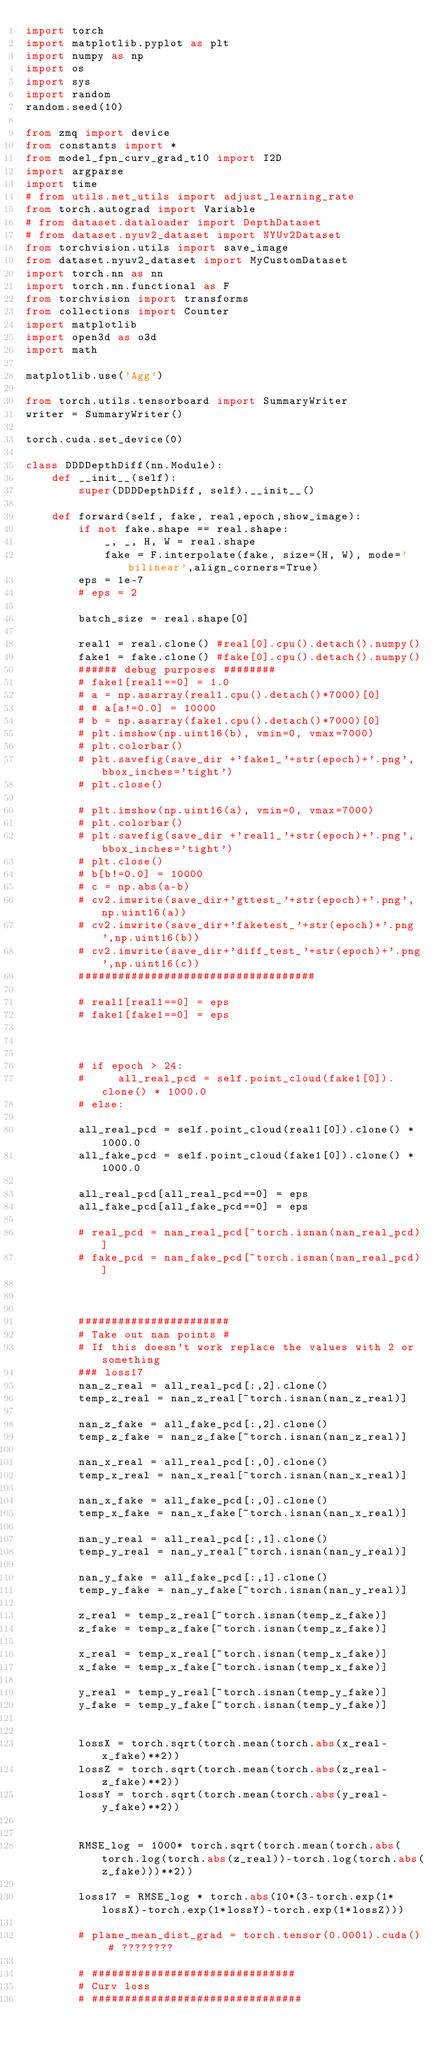<code> <loc_0><loc_0><loc_500><loc_500><_Python_>import torch
import matplotlib.pyplot as plt
import numpy as np
import os
import sys
import random
random.seed(10)

from zmq import device
from constants import *
from model_fpn_curv_grad_t10 import I2D
import argparse
import time
# from utils.net_utils import adjust_learning_rate
from torch.autograd import Variable
# from dataset.dataloader import DepthDataset
# from dataset.nyuv2_dataset import NYUv2Dataset
from torchvision.utils import save_image
from dataset.nyuv2_dataset import MyCustomDataset
import torch.nn as nn
import torch.nn.functional as F
from torchvision import transforms
from collections import Counter
import matplotlib
import open3d as o3d
import math

matplotlib.use('Agg')

from torch.utils.tensorboard import SummaryWriter
writer = SummaryWriter()

torch.cuda.set_device(0)

class DDDDepthDiff(nn.Module):
    def __init__(self):
        super(DDDDepthDiff, self).__init__()

    def forward(self, fake, real,epoch,show_image):
        if not fake.shape == real.shape:
            _, _, H, W = real.shape
            fake = F.interpolate(fake, size=(H, W), mode='bilinear',align_corners=True)
        eps = 1e-7
        # eps = 2

        batch_size = real.shape[0]
        
        real1 = real.clone() #real[0].cpu().detach().numpy()
        fake1 = fake.clone() #fake[0].cpu().detach().numpy()
        ###### debug purposes ########
        # fake1[real1==0] = 1.0
        # a = np.asarray(real1.cpu().detach()*7000)[0]
        # # a[a!=0.0] = 10000
        # b = np.asarray(fake1.cpu().detach()*7000)[0]
        # plt.imshow(np.uint16(b), vmin=0, vmax=7000)
        # plt.colorbar()
        # plt.savefig(save_dir +'fake1_'+str(epoch)+'.png',bbox_inches='tight')
        # plt.close()

        # plt.imshow(np.uint16(a), vmin=0, vmax=7000)
        # plt.colorbar()
        # plt.savefig(save_dir +'real1_'+str(epoch)+'.png',bbox_inches='tight')
        # plt.close()
        # b[b!=0.0] = 10000
        # c = np.abs(a-b)
        # cv2.imwrite(save_dir+'gttest_'+str(epoch)+'.png',np.uint16(a))
        # cv2.imwrite(save_dir+'faketest_'+str(epoch)+'.png',np.uint16(b))
        # cv2.imwrite(save_dir+'diff_test_'+str(epoch)+'.png',np.uint16(c))
        ####################################

        # real1[real1==0] = eps
        # fake1[fake1==0] = eps



        # if epoch > 24:
        #     all_real_pcd = self.point_cloud(fake1[0]).clone() * 1000.0
        # else:    

        all_real_pcd = self.point_cloud(real1[0]).clone() * 1000.0
        all_fake_pcd = self.point_cloud(fake1[0]).clone() * 1000.0

        all_real_pcd[all_real_pcd==0] = eps
        all_fake_pcd[all_fake_pcd==0] = eps

        # real_pcd = nan_real_pcd[~torch.isnan(nan_real_pcd)]
        # fake_pcd = nan_fake_pcd[~torch.isnan(nan_real_pcd)]

        
      
        #######################
        # Take out nan points #
        # If this doesn't work replace the values with 2 or something
        ### loss17
        nan_z_real = all_real_pcd[:,2].clone()
        temp_z_real = nan_z_real[~torch.isnan(nan_z_real)]
       
        nan_z_fake = all_fake_pcd[:,2].clone()
        temp_z_fake = nan_z_fake[~torch.isnan(nan_z_real)]
        
        nan_x_real = all_real_pcd[:,0].clone()
        temp_x_real = nan_x_real[~torch.isnan(nan_x_real)]
        
        nan_x_fake = all_fake_pcd[:,0].clone()
        temp_x_fake = nan_x_fake[~torch.isnan(nan_x_real)]
        
        nan_y_real = all_real_pcd[:,1].clone()
        temp_y_real = nan_y_real[~torch.isnan(nan_y_real)]
        
        nan_y_fake = all_fake_pcd[:,1].clone()
        temp_y_fake = nan_y_fake[~torch.isnan(nan_y_real)]

        z_real = temp_z_real[~torch.isnan(temp_z_fake)]
        z_fake = temp_z_fake[~torch.isnan(temp_z_fake)]

        x_real = temp_x_real[~torch.isnan(temp_x_fake)]
        x_fake = temp_x_fake[~torch.isnan(temp_x_fake)]

        y_real = temp_y_real[~torch.isnan(temp_y_fake)]
        y_fake = temp_y_fake[~torch.isnan(temp_y_fake)]
        

        lossX = torch.sqrt(torch.mean(torch.abs(x_real-x_fake)**2))
        lossZ = torch.sqrt(torch.mean(torch.abs(z_real-z_fake)**2))
        lossY = torch.sqrt(torch.mean(torch.abs(y_real-y_fake)**2))
        
       
        RMSE_log = 1000* torch.sqrt(torch.mean(torch.abs(torch.log(torch.abs(z_real))-torch.log(torch.abs(z_fake)))**2))

        loss17 = RMSE_log * torch.abs(10*(3-torch.exp(1*lossX)-torch.exp(1*lossY)-torch.exp(1*lossZ)))
        
        # plane_mean_dist_grad = torch.tensor(0.0001).cuda() # ????????
        
        # ###############################
        # Curv loss
        # ################################</code> 